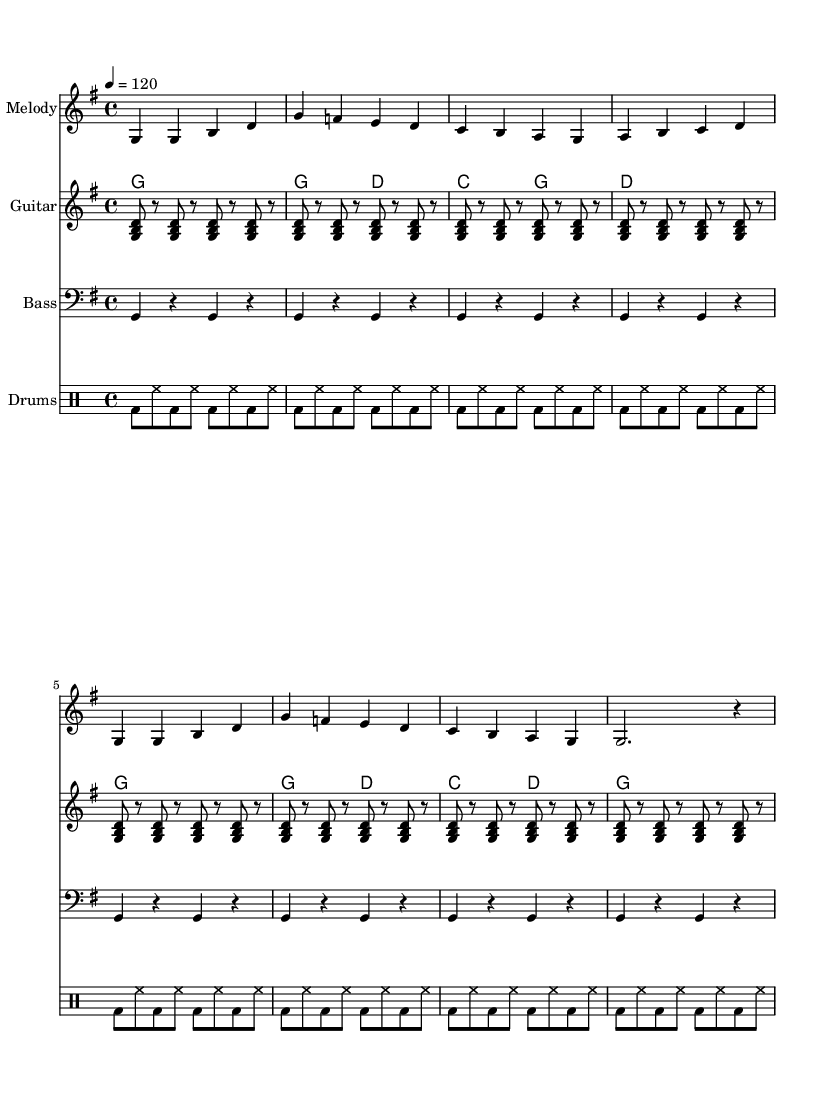What is the key signature of this music? The key signature indicates G major, which has one sharp (F#). This can be confirmed by looking at the beginning of the staff where the sharp signs are placed.
Answer: G major What is the time signature of this music? The time signature is found at the beginning of the staff. It is displayed as "4/4", meaning there are 4 beats in each measure, and the quarter note gets one beat.
Answer: 4/4 What is the tempo marking of this music? The tempo marking is indicated in the score with "4 = 120", which signifies that each quarter note is to be played at a speed of 120 beats per minute. This tells us how fast the song should be played.
Answer: 120 How many measures are present in this piece? By counting the number of vertical lines (bars) that segment the staff, we can determine the number of measures. There are 8 measures within this piece, as indicated by the corresponding bar lines and repetitive sections.
Answer: 8 What instruments are featured in the score? The score displays parts for four instruments: "Melody," "Guitar," "Bass," and "Drums." These are clearly labeled at the beginning of each staff section in the score.
Answer: Melody, Guitar, Bass, Drums What style of music does this piece exemplify? The upbeat tempo, the use of typical instruments like guitar and drums, and the lyrical content focused on professional achievements indicate that this piece is Country music. The themes and instrumentation are characteristic of the genre.
Answer: Country What is the lyrical theme of this piece? The lyrics refer to achieving a degree and progressing in a career, suggesting a celebration of professional milestones. The tone is positive and reflective, common in country tracks that focus on life events.
Answer: Career milestones 